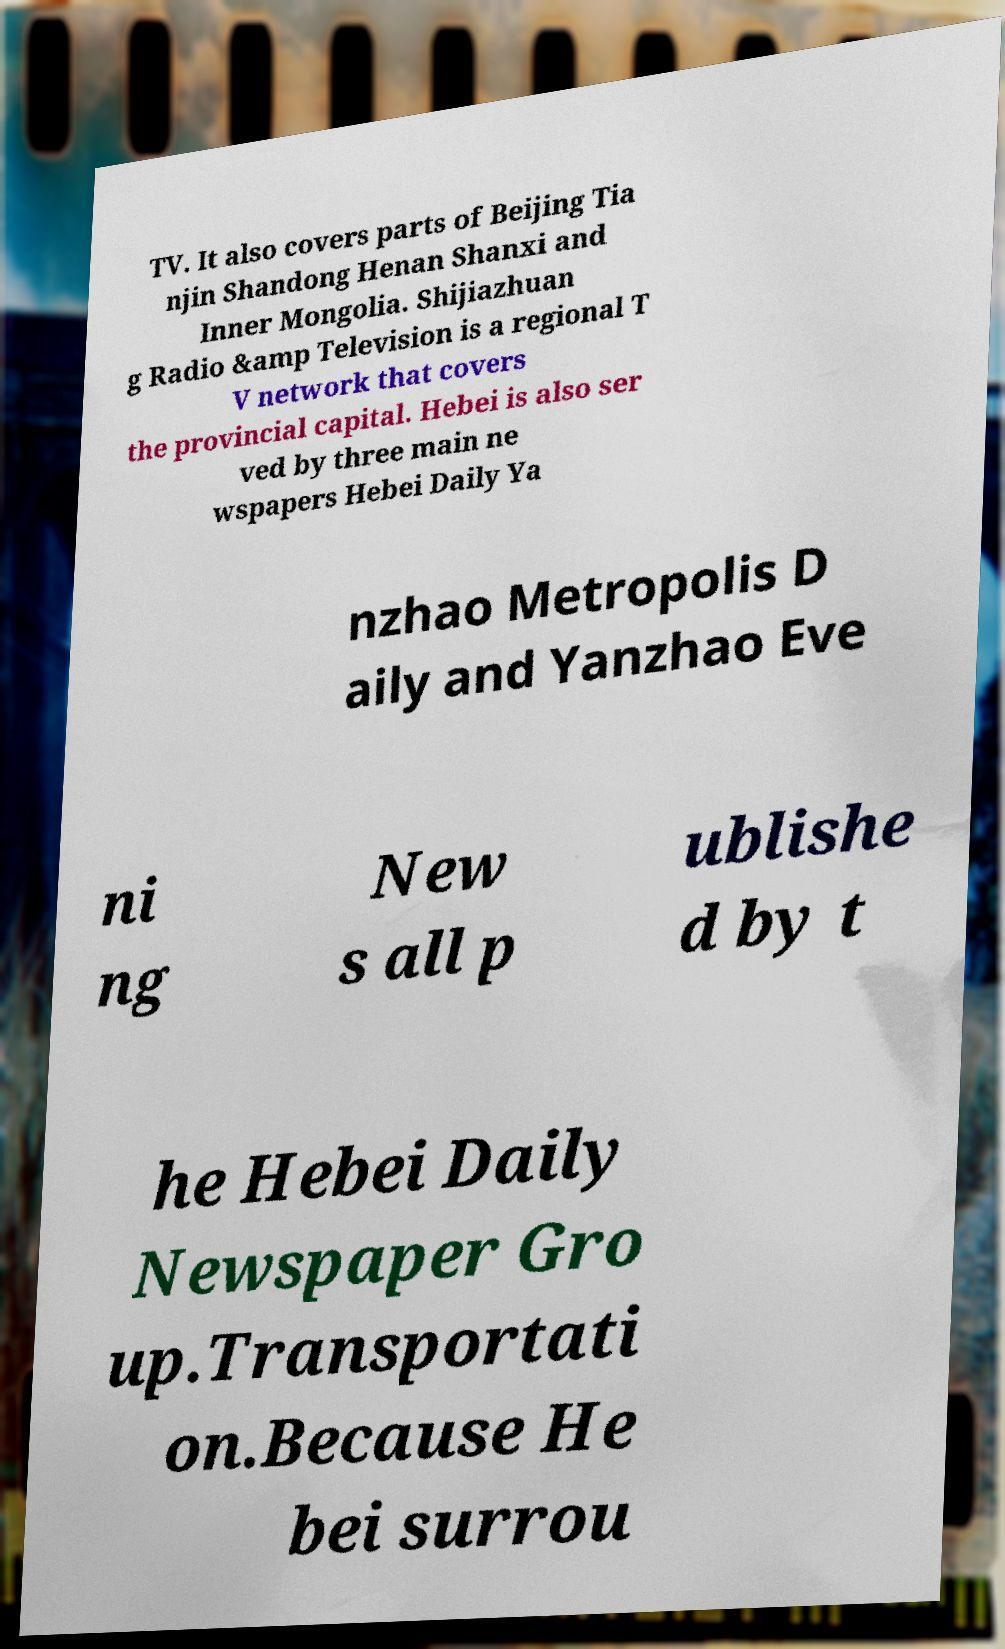Can you read and provide the text displayed in the image?This photo seems to have some interesting text. Can you extract and type it out for me? TV. It also covers parts of Beijing Tia njin Shandong Henan Shanxi and Inner Mongolia. Shijiazhuan g Radio &amp Television is a regional T V network that covers the provincial capital. Hebei is also ser ved by three main ne wspapers Hebei Daily Ya nzhao Metropolis D aily and Yanzhao Eve ni ng New s all p ublishe d by t he Hebei Daily Newspaper Gro up.Transportati on.Because He bei surrou 